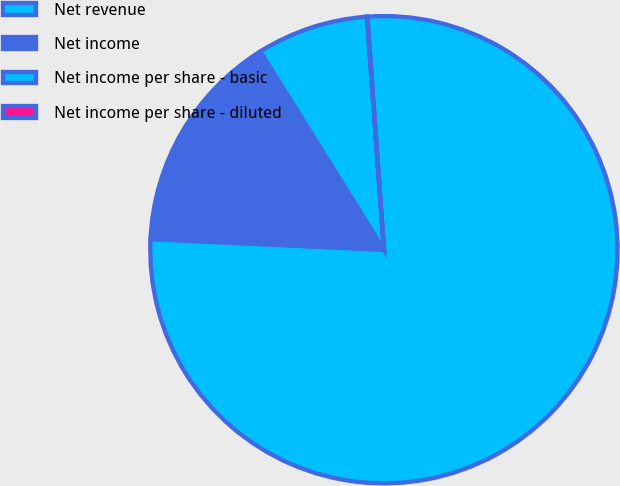Convert chart. <chart><loc_0><loc_0><loc_500><loc_500><pie_chart><fcel>Net revenue<fcel>Net income<fcel>Net income per share - basic<fcel>Net income per share - diluted<nl><fcel>76.86%<fcel>15.4%<fcel>7.71%<fcel>0.03%<nl></chart> 